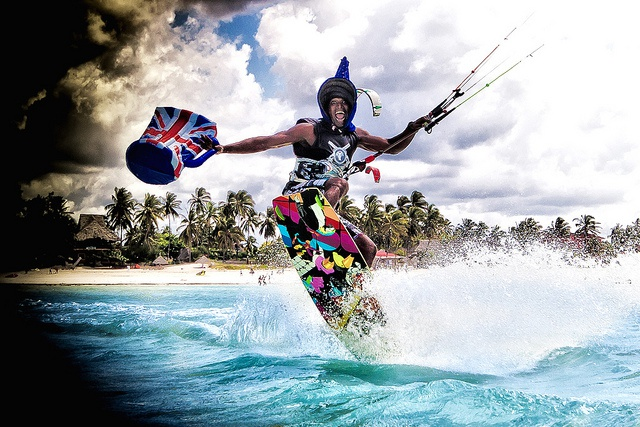Describe the objects in this image and their specific colors. I can see surfboard in black, lightgray, darkgray, and gray tones and people in black, gray, brown, and lightgray tones in this image. 